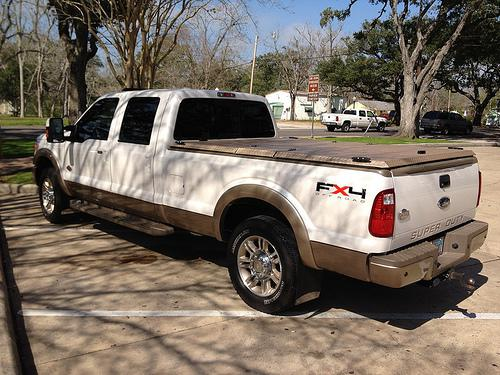Question: who is standing beside the truck?
Choices:
A. 1 man.
B. A gas station attendant.
C. A woman.
D. No one.
Answer with the letter. Answer: D Question: what type of truck is this?
Choices:
A. Dump truck.
B. FX4 Off Road.
C. Garbage truck.
D. Semi.
Answer with the letter. Answer: B Question: why is the truck in the lot?
Choices:
A. To park.
B. It's leaving.
C. To be painted.
D. To be washed.
Answer with the letter. Answer: A Question: where is this location?
Choices:
A. Driveway.
B. Garage.
C. Parking lot.
D. Racetrack.
Answer with the letter. Answer: C Question: how many trucks are shown?
Choices:
A. One.
B. Four.
C. Two.
D. Five.
Answer with the letter. Answer: C Question: what color is the sign?
Choices:
A. Red.
B. Yellow.
C. Brown.
D. Orange.
Answer with the letter. Answer: C 